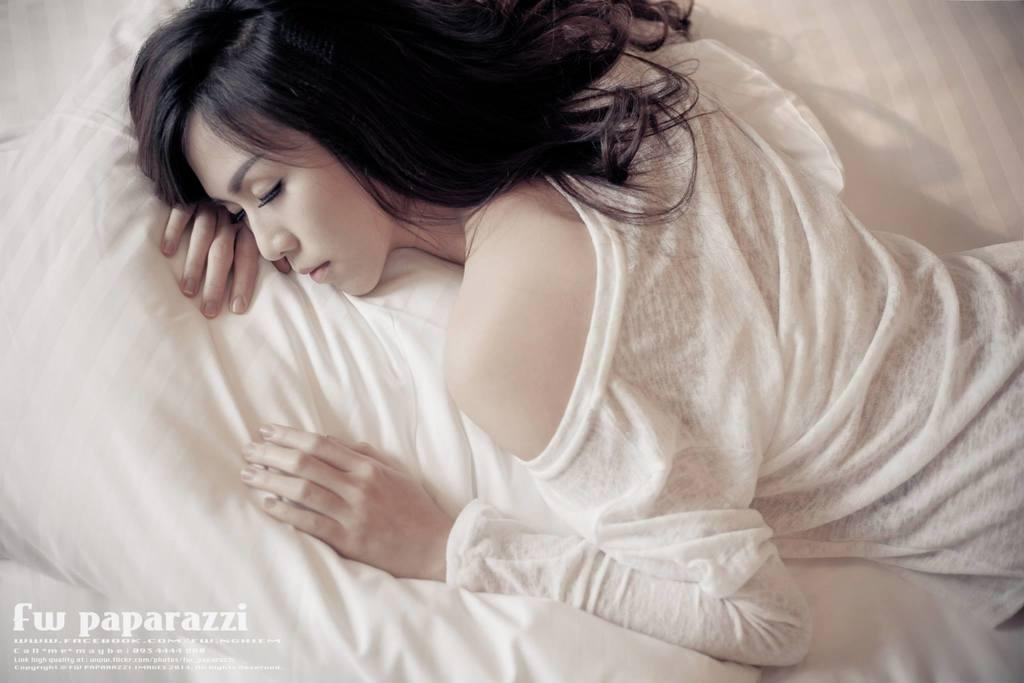Who is present in the image? There is a woman in the image. What is the woman doing in the image? The woman is sleeping on a bed. Is there any text present in the image? Yes, there is some text at the bottom left corner of the image. What type of animal is present in the image? There is no animal present in the image; it features a woman sleeping on a bed. What hope does the scarecrow have in the image? There is no scarecrow present in the image, so it is not possible to determine any hopes it might have. 